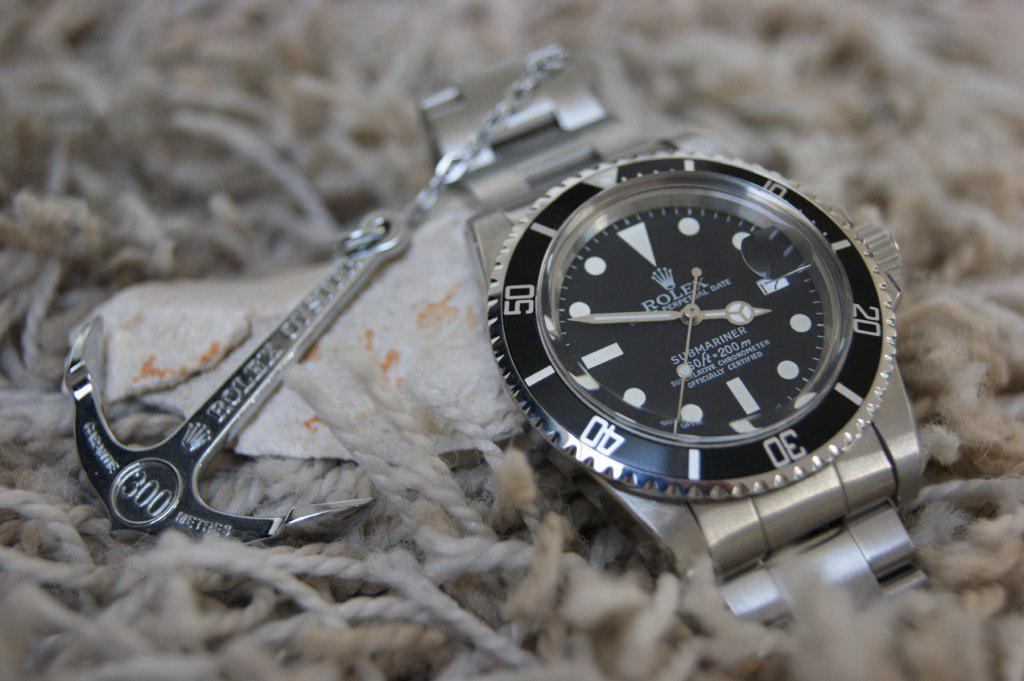What object is the main focus of the image? The main focus of the image is a wrist watch. Are there any additional features attached to the wrist watch? Yes, there is a key chain attached to the wrist watch. What design is featured on the key chain? The key chain features an anchor design. How are the wrist watch and key chain displayed in the image? They are placed on threads. Can you tell me how many stars are visible on the wrist watch in the image? There are no stars visible on the wrist watch in the image. What type of bee can be seen buzzing around the key chain in the image? There are no bees present in the image. 